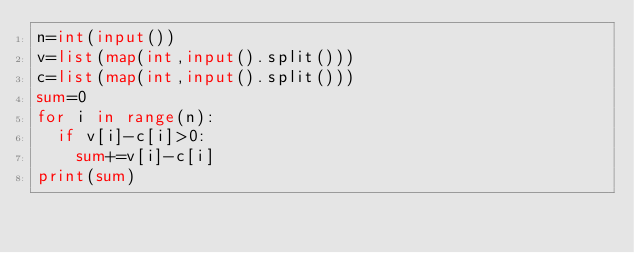Convert code to text. <code><loc_0><loc_0><loc_500><loc_500><_Python_>n=int(input())
v=list(map(int,input().split()))
c=list(map(int,input().split()))
sum=0
for i in range(n):
  if v[i]-c[i]>0:
    sum+=v[i]-c[i]
print(sum)</code> 